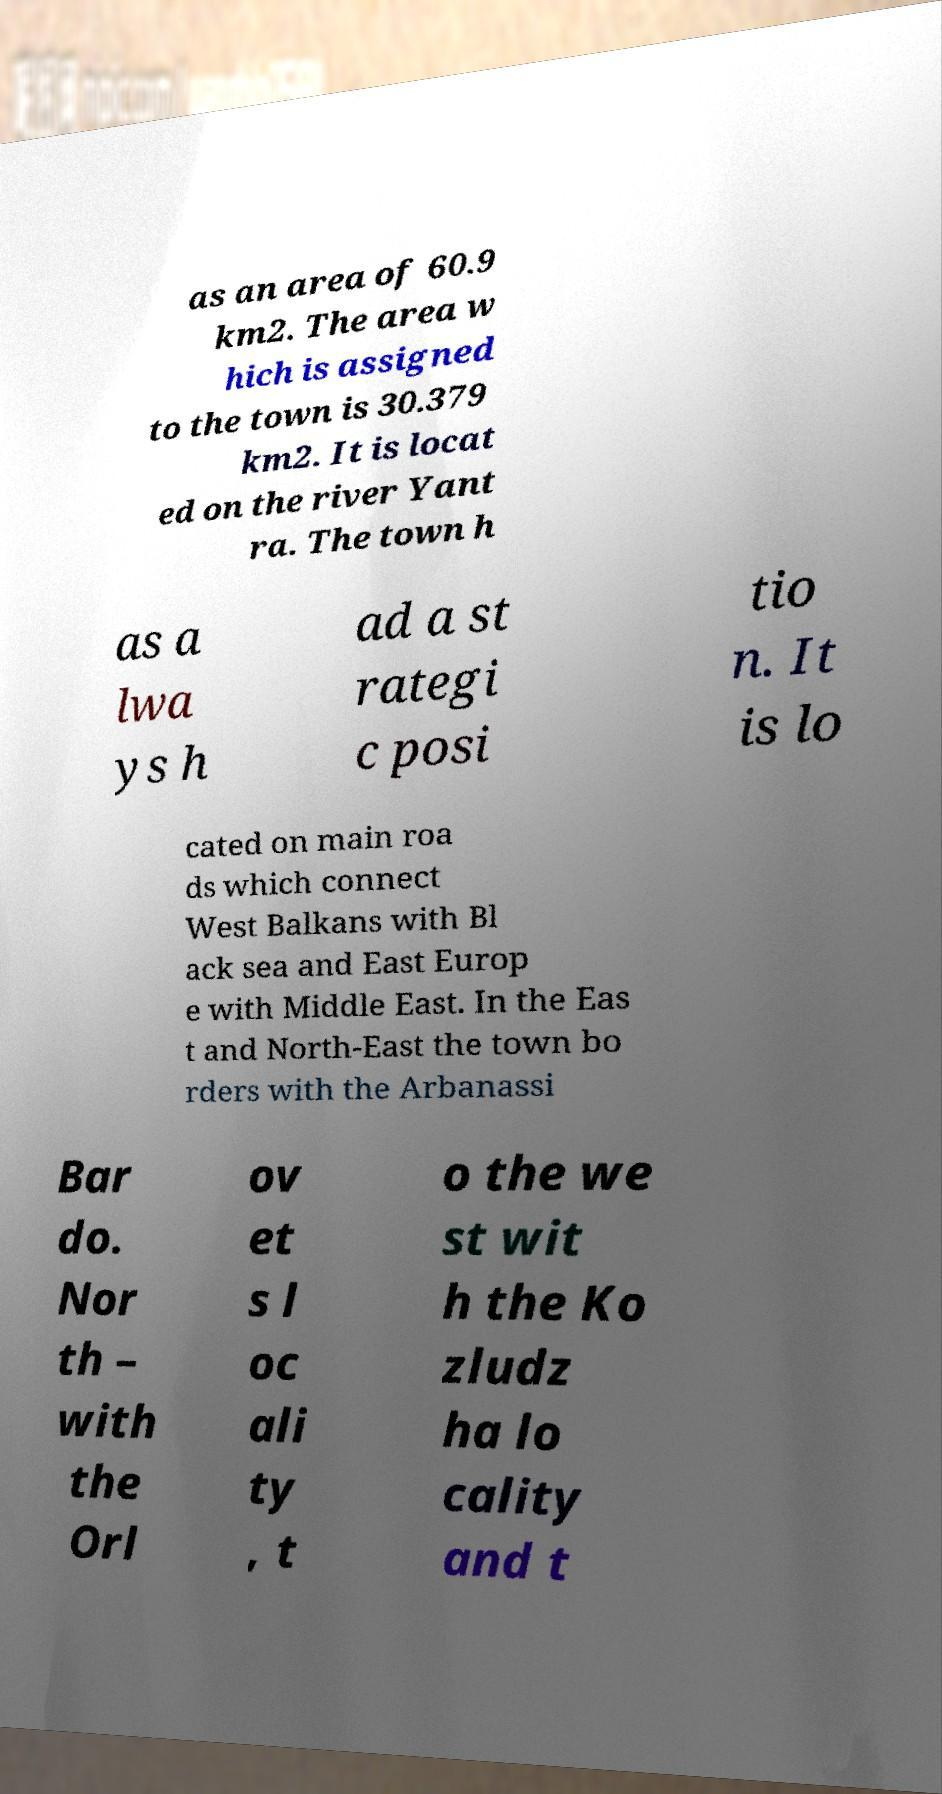Please identify and transcribe the text found in this image. as an area of 60.9 km2. The area w hich is assigned to the town is 30.379 km2. It is locat ed on the river Yant ra. The town h as a lwa ys h ad a st rategi c posi tio n. It is lo cated on main roa ds which connect West Balkans with Bl ack sea and East Europ e with Middle East. In the Eas t and North-East the town bo rders with the Arbanassi Bar do. Nor th – with the Orl ov et s l oc ali ty , t o the we st wit h the Ko zludz ha lo cality and t 